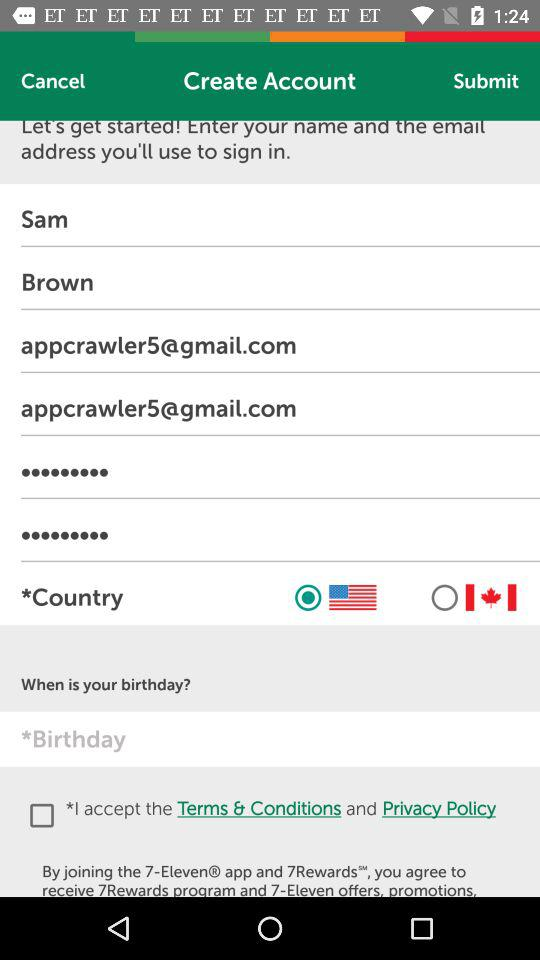What is the email address? The email address is appcrawler5@gmail.com. 